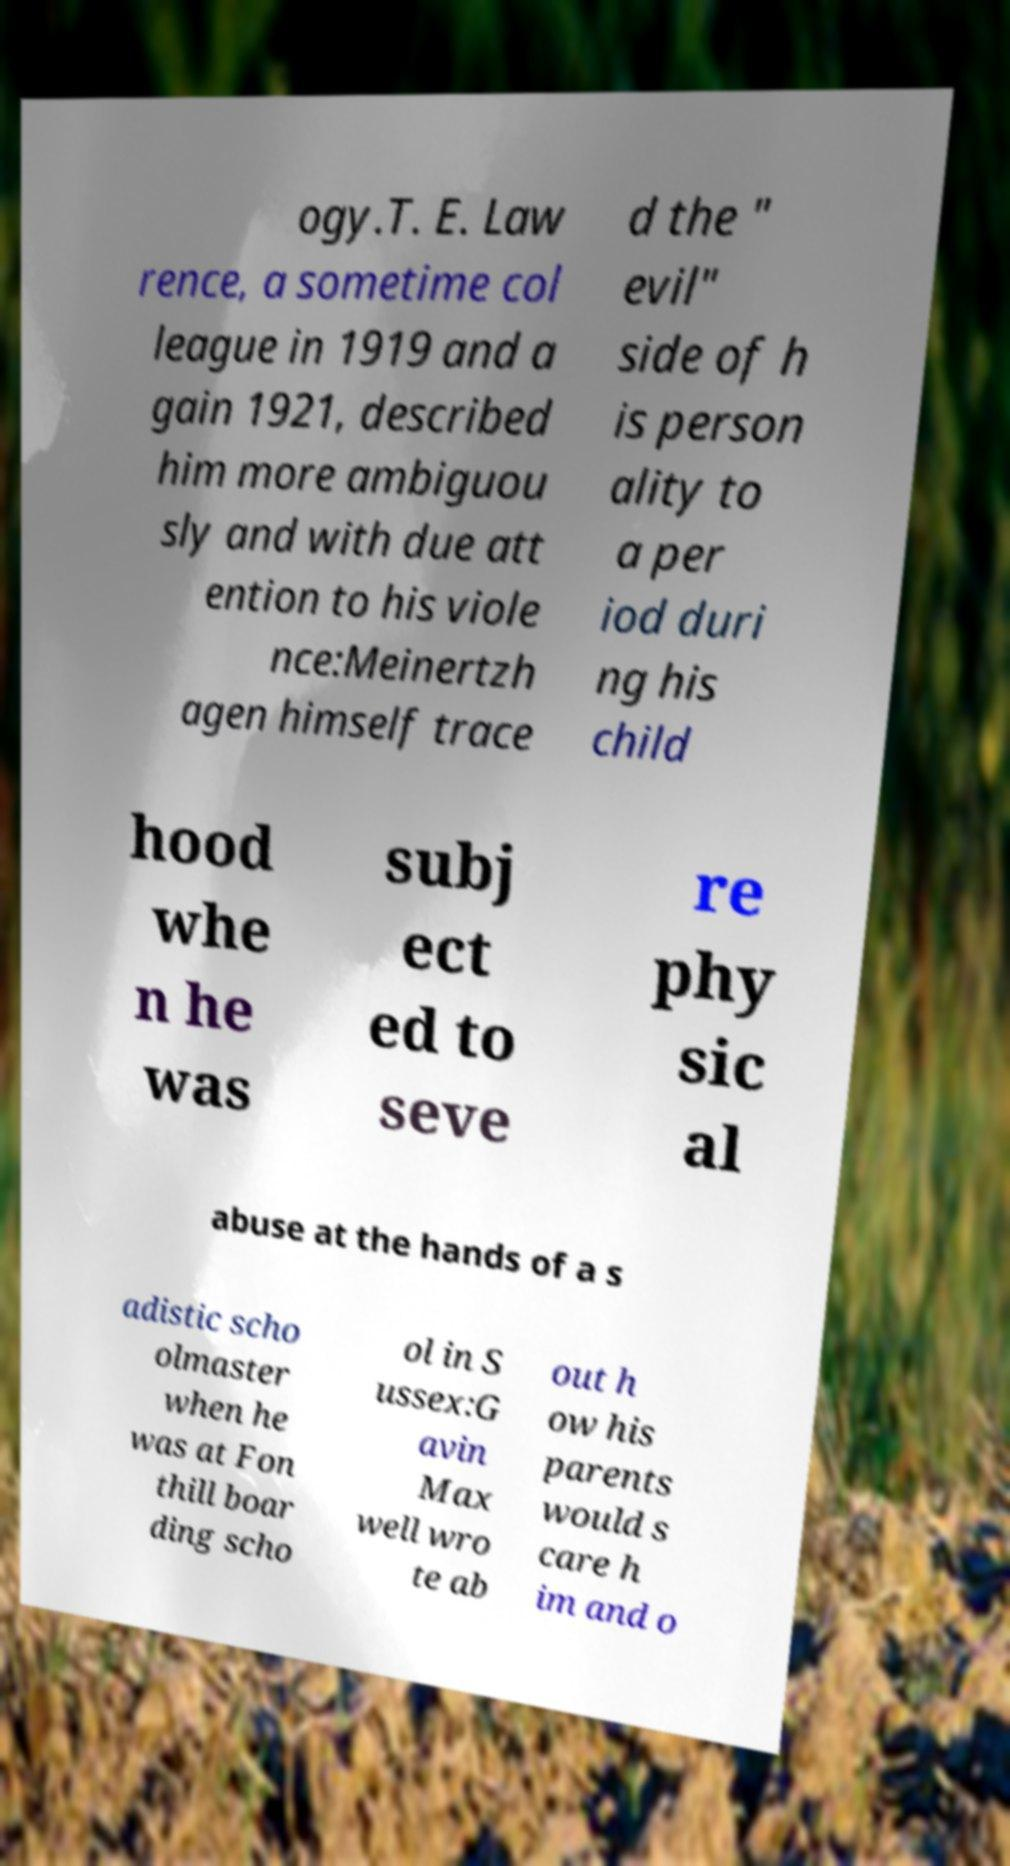There's text embedded in this image that I need extracted. Can you transcribe it verbatim? ogy.T. E. Law rence, a sometime col league in 1919 and a gain 1921, described him more ambiguou sly and with due att ention to his viole nce:Meinertzh agen himself trace d the " evil" side of h is person ality to a per iod duri ng his child hood whe n he was subj ect ed to seve re phy sic al abuse at the hands of a s adistic scho olmaster when he was at Fon thill boar ding scho ol in S ussex:G avin Max well wro te ab out h ow his parents would s care h im and o 